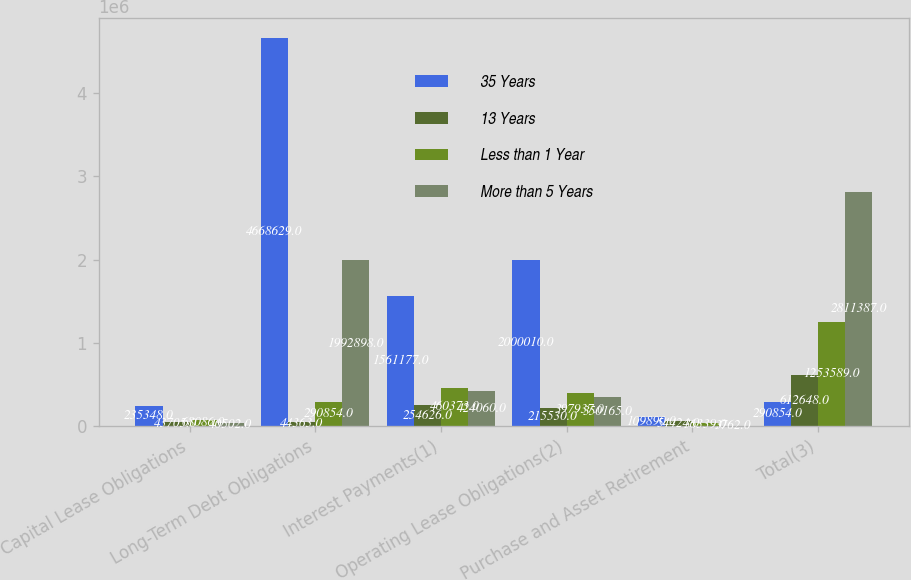<chart> <loc_0><loc_0><loc_500><loc_500><stacked_bar_chart><ecel><fcel>Capital Lease Obligations<fcel>Long-Term Debt Obligations<fcel>Interest Payments(1)<fcel>Operating Lease Obligations(2)<fcel>Purchase and Asset Retirement<fcel>Total(3)<nl><fcel>35 Years<fcel>235348<fcel>4.66863e+06<fcel>1.56118e+06<fcel>2.00001e+06<fcel>109890<fcel>290854<nl><fcel>13 Years<fcel>43705<fcel>44363<fcel>254626<fcel>215530<fcel>54424<fcel>612648<nl><fcel>Less than 1 Year<fcel>68086<fcel>290854<fcel>460373<fcel>397937<fcel>36339<fcel>1.25359e+06<nl><fcel>More than 5 Years<fcel>40502<fcel>1.9929e+06<fcel>424060<fcel>350165<fcel>3762<fcel>2.81139e+06<nl></chart> 